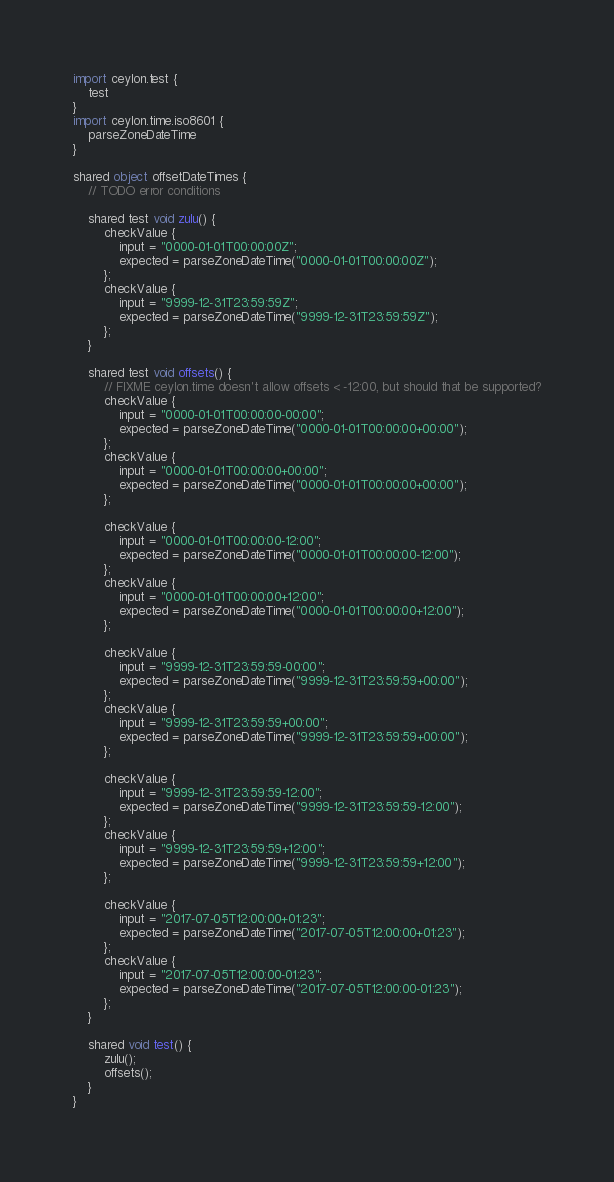Convert code to text. <code><loc_0><loc_0><loc_500><loc_500><_Ceylon_>import ceylon.test {
    test
}
import ceylon.time.iso8601 {
    parseZoneDateTime
}

shared object offsetDateTimes {
    // TODO error conditions

    shared test void zulu() {
        checkValue {
            input = "0000-01-01T00:00:00Z";
            expected = parseZoneDateTime("0000-01-01T00:00:00Z");
        };
        checkValue {
            input = "9999-12-31T23:59:59Z";
            expected = parseZoneDateTime("9999-12-31T23:59:59Z");
        };
    }

    shared test void offsets() {
        // FIXME ceylon.time doesn't allow offsets < -12:00, but should that be supported?
        checkValue {
            input = "0000-01-01T00:00:00-00:00";
            expected = parseZoneDateTime("0000-01-01T00:00:00+00:00");
        };
        checkValue {
            input = "0000-01-01T00:00:00+00:00";
            expected = parseZoneDateTime("0000-01-01T00:00:00+00:00");
        };
        
        checkValue {
            input = "0000-01-01T00:00:00-12:00";
            expected = parseZoneDateTime("0000-01-01T00:00:00-12:00");
        };
        checkValue {
            input = "0000-01-01T00:00:00+12:00";
            expected = parseZoneDateTime("0000-01-01T00:00:00+12:00");
        };

        checkValue {
            input = "9999-12-31T23:59:59-00:00";
            expected = parseZoneDateTime("9999-12-31T23:59:59+00:00");
        };
        checkValue {
            input = "9999-12-31T23:59:59+00:00";
            expected = parseZoneDateTime("9999-12-31T23:59:59+00:00");
        };

        checkValue {
            input = "9999-12-31T23:59:59-12:00";
            expected = parseZoneDateTime("9999-12-31T23:59:59-12:00");
        };
        checkValue {
            input = "9999-12-31T23:59:59+12:00";
            expected = parseZoneDateTime("9999-12-31T23:59:59+12:00");
        };

        checkValue {
            input = "2017-07-05T12:00:00+01:23";
            expected = parseZoneDateTime("2017-07-05T12:00:00+01:23");
        };
        checkValue {
            input = "2017-07-05T12:00:00-01:23";
            expected = parseZoneDateTime("2017-07-05T12:00:00-01:23");
        };
    }

    shared void test() {
        zulu();
        offsets();
    }
}
</code> 